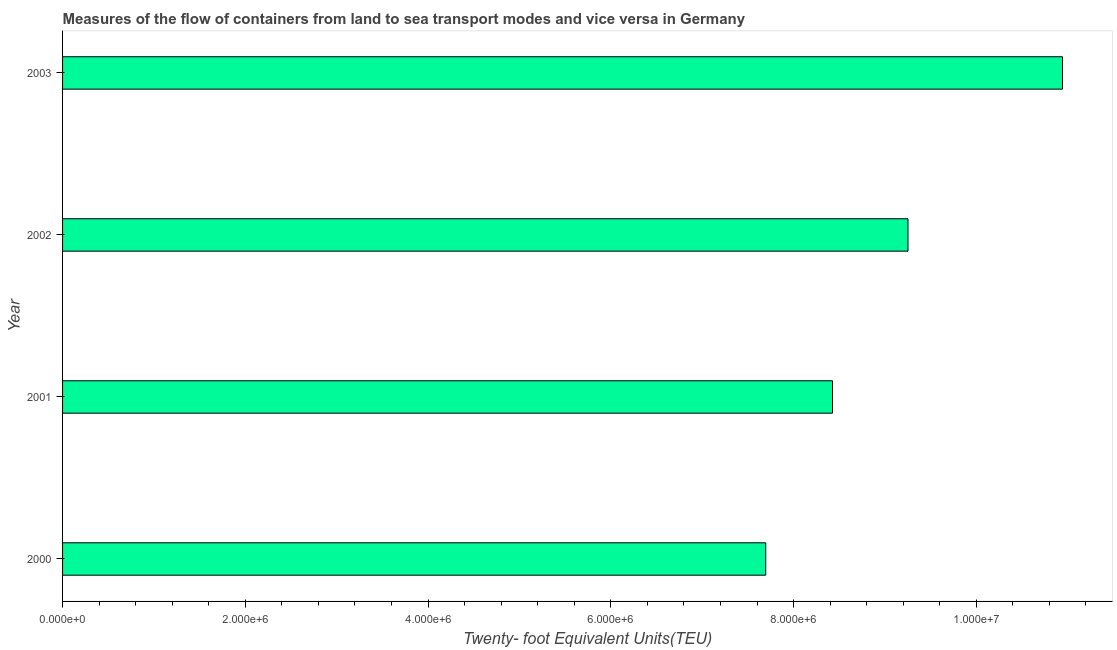Does the graph contain any zero values?
Offer a terse response. No. Does the graph contain grids?
Give a very brief answer. No. What is the title of the graph?
Give a very brief answer. Measures of the flow of containers from land to sea transport modes and vice versa in Germany. What is the label or title of the X-axis?
Give a very brief answer. Twenty- foot Equivalent Units(TEU). What is the label or title of the Y-axis?
Your response must be concise. Year. What is the container port traffic in 2002?
Your answer should be compact. 9.25e+06. Across all years, what is the maximum container port traffic?
Keep it short and to the point. 1.09e+07. Across all years, what is the minimum container port traffic?
Make the answer very short. 7.70e+06. In which year was the container port traffic maximum?
Your response must be concise. 2003. What is the sum of the container port traffic?
Your answer should be very brief. 3.63e+07. What is the difference between the container port traffic in 2001 and 2002?
Your answer should be compact. -8.26e+05. What is the average container port traffic per year?
Make the answer very short. 9.08e+06. What is the median container port traffic?
Your answer should be very brief. 8.84e+06. Do a majority of the years between 2003 and 2000 (inclusive) have container port traffic greater than 10800000 TEU?
Offer a very short reply. Yes. What is the ratio of the container port traffic in 2001 to that in 2002?
Ensure brevity in your answer.  0.91. What is the difference between the highest and the second highest container port traffic?
Offer a very short reply. 1.69e+06. Is the sum of the container port traffic in 2000 and 2002 greater than the maximum container port traffic across all years?
Provide a short and direct response. Yes. What is the difference between the highest and the lowest container port traffic?
Keep it short and to the point. 3.25e+06. How many bars are there?
Your answer should be compact. 4. How many years are there in the graph?
Keep it short and to the point. 4. What is the difference between two consecutive major ticks on the X-axis?
Give a very brief answer. 2.00e+06. Are the values on the major ticks of X-axis written in scientific E-notation?
Offer a very short reply. Yes. What is the Twenty- foot Equivalent Units(TEU) in 2000?
Your response must be concise. 7.70e+06. What is the Twenty- foot Equivalent Units(TEU) in 2001?
Provide a succinct answer. 8.43e+06. What is the Twenty- foot Equivalent Units(TEU) in 2002?
Give a very brief answer. 9.25e+06. What is the Twenty- foot Equivalent Units(TEU) in 2003?
Provide a short and direct response. 1.09e+07. What is the difference between the Twenty- foot Equivalent Units(TEU) in 2000 and 2001?
Your response must be concise. -7.31e+05. What is the difference between the Twenty- foot Equivalent Units(TEU) in 2000 and 2002?
Provide a succinct answer. -1.56e+06. What is the difference between the Twenty- foot Equivalent Units(TEU) in 2000 and 2003?
Make the answer very short. -3.25e+06. What is the difference between the Twenty- foot Equivalent Units(TEU) in 2001 and 2002?
Make the answer very short. -8.26e+05. What is the difference between the Twenty- foot Equivalent Units(TEU) in 2001 and 2003?
Offer a terse response. -2.52e+06. What is the difference between the Twenty- foot Equivalent Units(TEU) in 2002 and 2003?
Offer a very short reply. -1.69e+06. What is the ratio of the Twenty- foot Equivalent Units(TEU) in 2000 to that in 2001?
Your response must be concise. 0.91. What is the ratio of the Twenty- foot Equivalent Units(TEU) in 2000 to that in 2002?
Give a very brief answer. 0.83. What is the ratio of the Twenty- foot Equivalent Units(TEU) in 2000 to that in 2003?
Provide a succinct answer. 0.7. What is the ratio of the Twenty- foot Equivalent Units(TEU) in 2001 to that in 2002?
Your answer should be very brief. 0.91. What is the ratio of the Twenty- foot Equivalent Units(TEU) in 2001 to that in 2003?
Give a very brief answer. 0.77. What is the ratio of the Twenty- foot Equivalent Units(TEU) in 2002 to that in 2003?
Give a very brief answer. 0.84. 